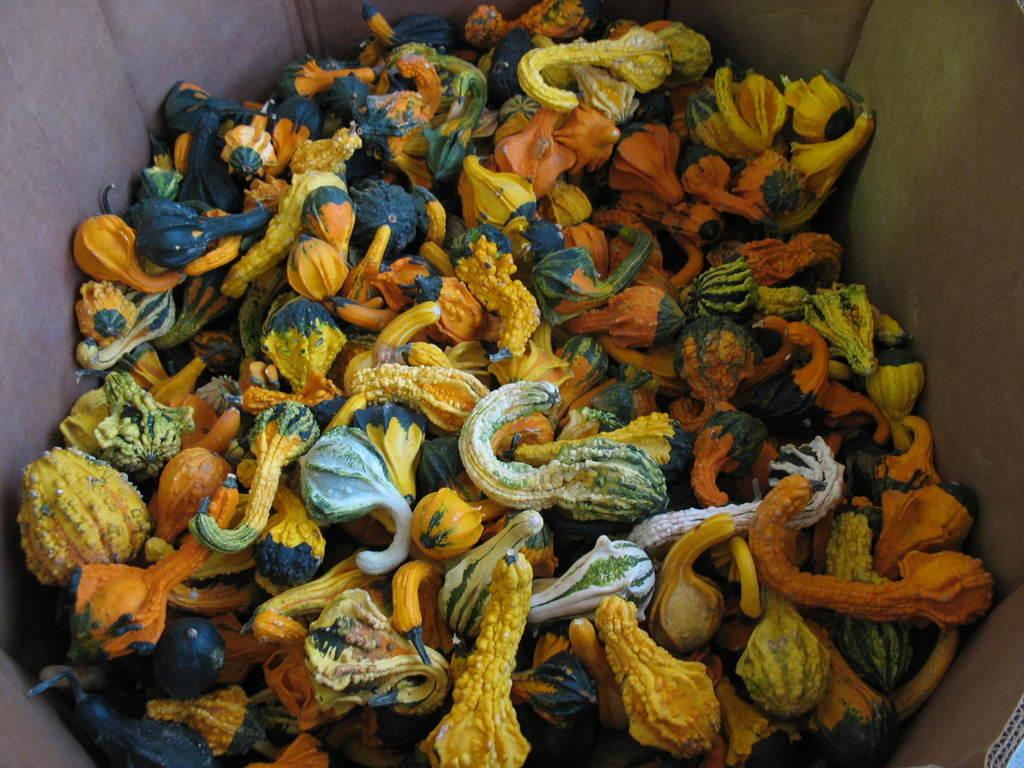What type of vegetables are in the image? There are gourd vegetables in the image. How are the gourd vegetables stored in the image? The gourd vegetables are in a cardboard box. Where is the cardboard box located in the image? The cardboard box is in the foreground of the image. What type of glove can be seen in the image? There is no glove present in the image. Is there any oil visible in the image? There is no oil visible in the image. 